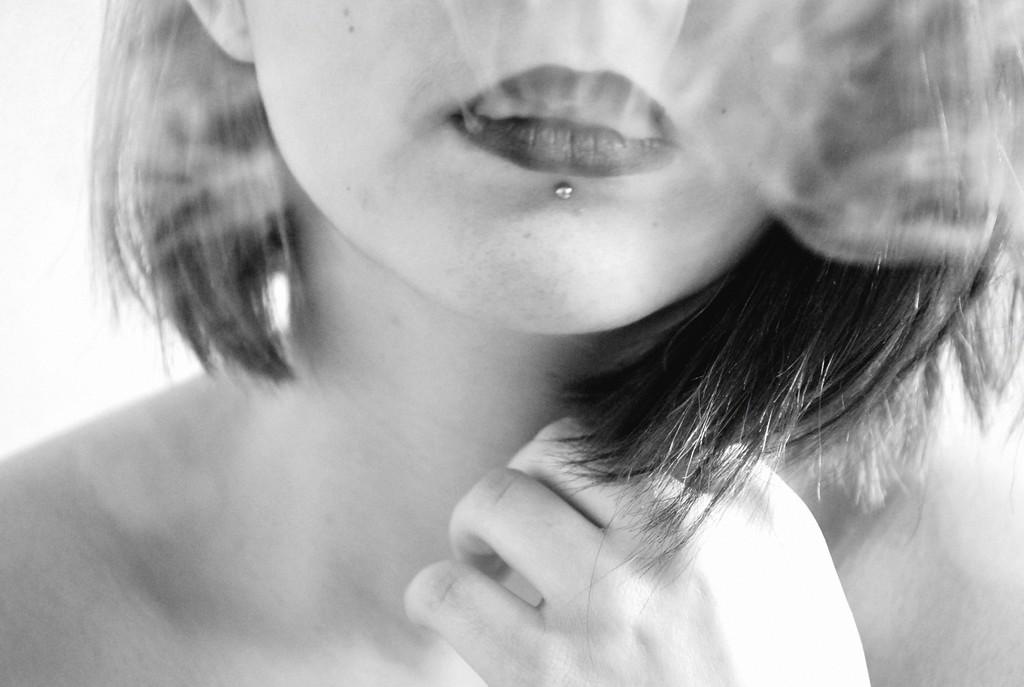What part of the woman's body is visible in the image? The image shows a woman's mouth and neck. What is the woman doing with her hand in the image? The woman's hand is on her neck. What can be seen attached to the woman's mouth? There is a steel hook under her lip. What type of humor can be seen in the woman's expression in the image? The image does not show the woman's expression, so it is not possible to determine if there is any humor present. 